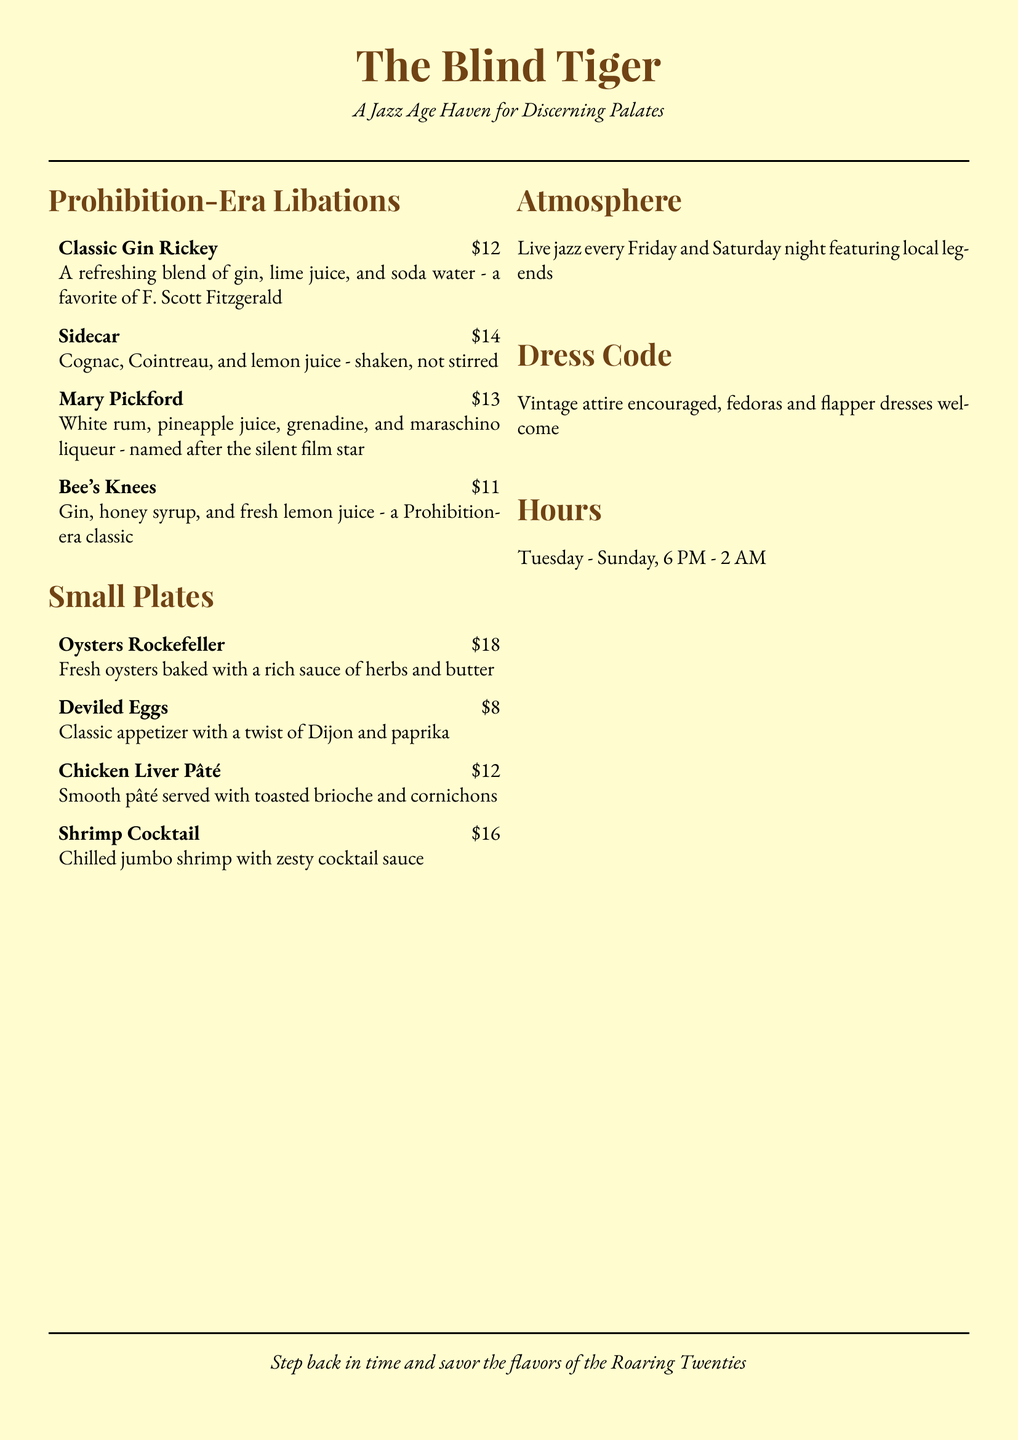What is the name of the establishment? The name of the restaurant, as indicated at the top of the document, is "The Blind Tiger."
Answer: The Blind Tiger What is the price of a Sidecar? The price listed next to the Sidecar drink is $14.
Answer: $14 What type of live music is featured? The document states that live jazz is performed every Friday and Saturday night.
Answer: Jazz What is the dress code for the restaurant? The dress code encourages vintage attire, with specifics like fedoras and flapper dresses.
Answer: Vintage attire What is the closing time on Sundays? According to the hours section, the restaurant closes at 2 AM on Sundays.
Answer: 2 AM What key ingredient is in the Bee's Knees? The Bee's Knees cocktail is made with gin, honey syrup, and fresh lemon juice; the key ingredient here is honey syrup.
Answer: Honey syrup How much do Oysters Rockefeller cost? The cost for Oysters Rockefeller is listed as $18.
Answer: $18 Which drink is named after a silent film star? The drink named after a silent film star is "Mary Pickford."
Answer: Mary Pickford On which days is the restaurant open? The document indicates that the restaurant is open from Tuesday to Sunday.
Answer: Tuesday - Sunday 